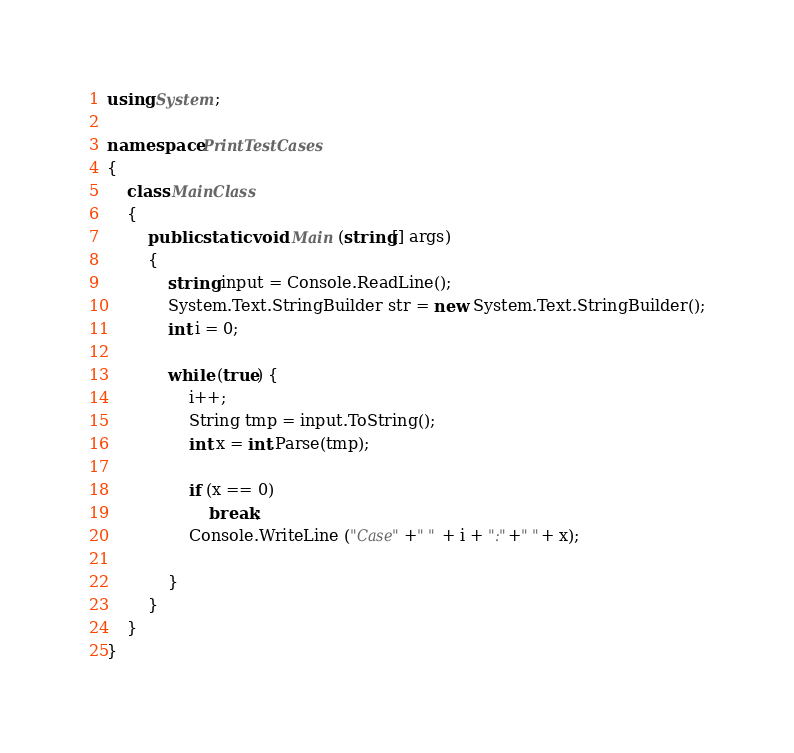Convert code to text. <code><loc_0><loc_0><loc_500><loc_500><_C#_>using System;

namespace PrintTestCases
{
	class MainClass
	{
		public static void Main (string[] args)
		{
			string input = Console.ReadLine();
			System.Text.StringBuilder str = new System.Text.StringBuilder();
			int i = 0;

			while (true) {
				i++;
				String tmp = input.ToString();
				int x = int.Parse(tmp);

				if (x == 0)
					break;
				Console.WriteLine ("Case"+" " + i + ":"+" "+ x);

			}
		}
	}
}</code> 